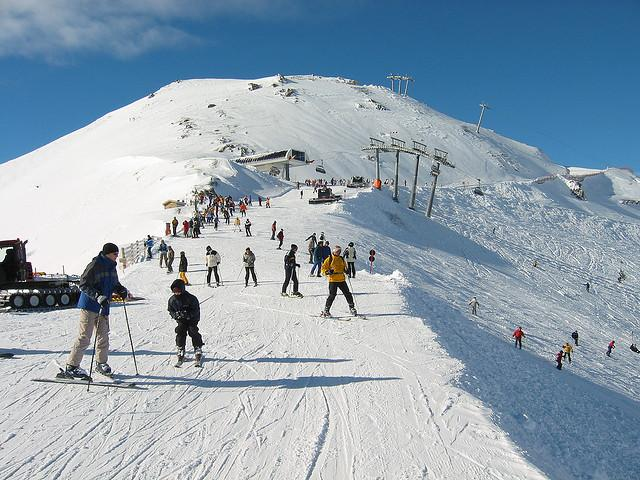What sort of skill is required at the slope in the foreground here? Please explain your reasoning. beginner. There is a child skiing down the foreground slope. 